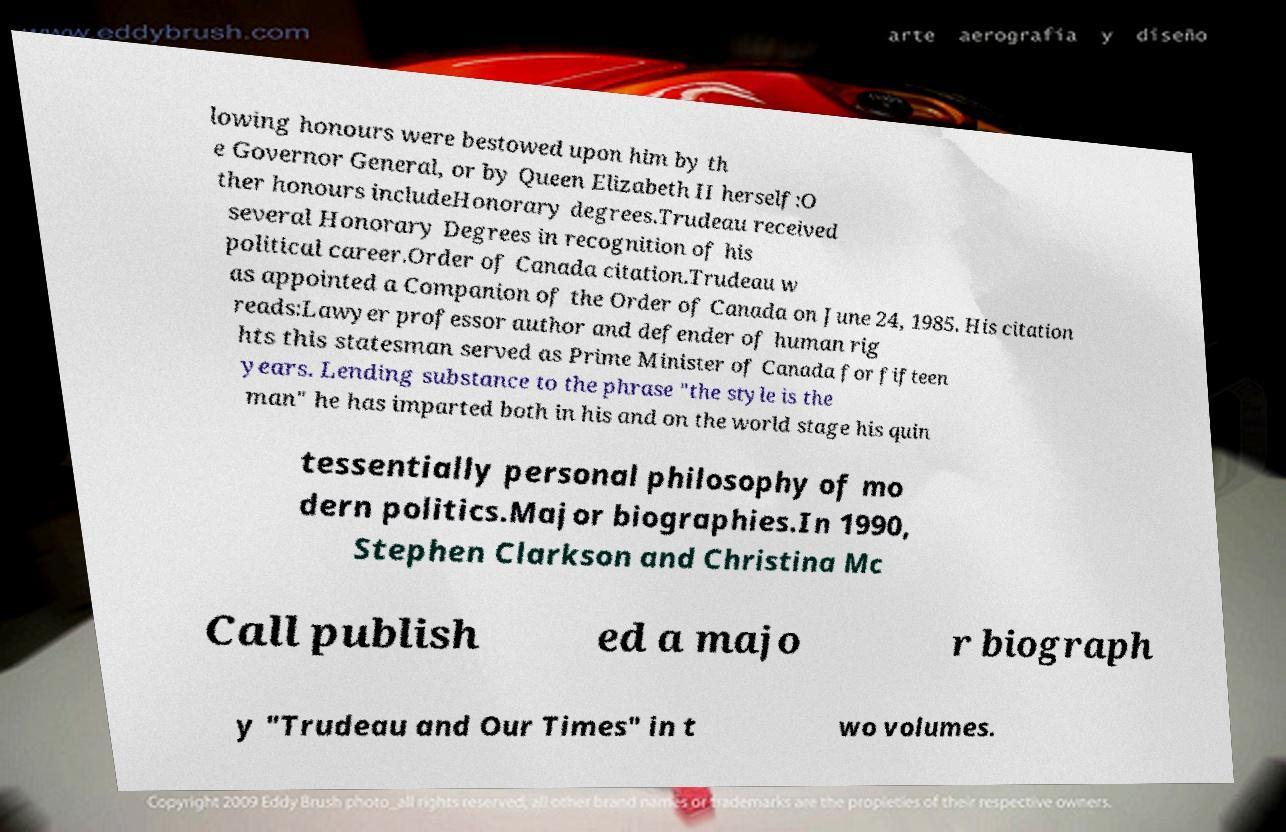What messages or text are displayed in this image? I need them in a readable, typed format. lowing honours were bestowed upon him by th e Governor General, or by Queen Elizabeth II herself:O ther honours includeHonorary degrees.Trudeau received several Honorary Degrees in recognition of his political career.Order of Canada citation.Trudeau w as appointed a Companion of the Order of Canada on June 24, 1985. His citation reads:Lawyer professor author and defender of human rig hts this statesman served as Prime Minister of Canada for fifteen years. Lending substance to the phrase "the style is the man" he has imparted both in his and on the world stage his quin tessentially personal philosophy of mo dern politics.Major biographies.In 1990, Stephen Clarkson and Christina Mc Call publish ed a majo r biograph y "Trudeau and Our Times" in t wo volumes. 